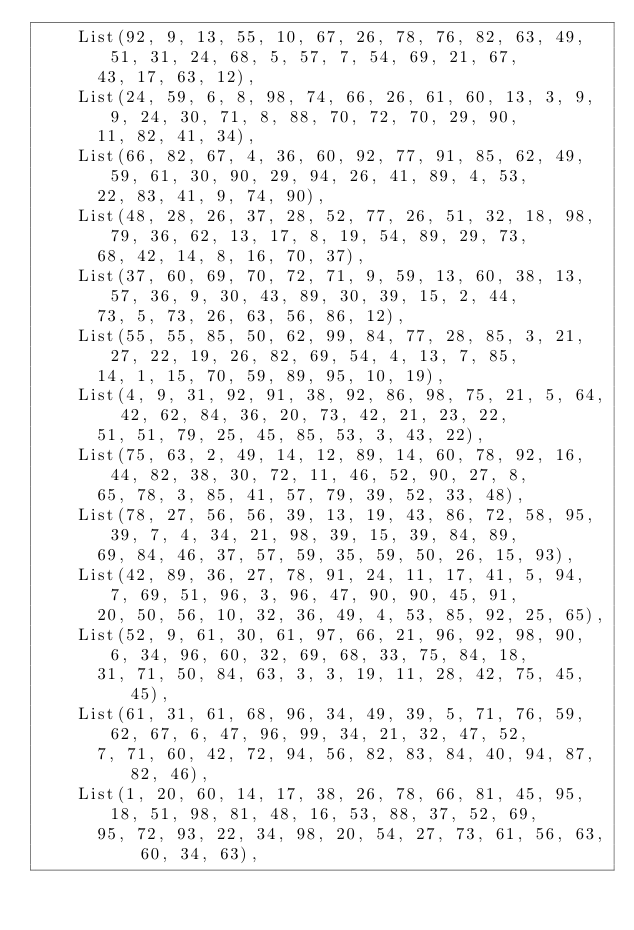Convert code to text. <code><loc_0><loc_0><loc_500><loc_500><_Scala_>    List(92, 9, 13, 55, 10, 67, 26, 78, 76, 82, 63, 49, 51, 31, 24, 68, 5, 57, 7, 54, 69, 21, 67,
      43, 17, 63, 12),
    List(24, 59, 6, 8, 98, 74, 66, 26, 61, 60, 13, 3, 9, 9, 24, 30, 71, 8, 88, 70, 72, 70, 29, 90,
      11, 82, 41, 34),
    List(66, 82, 67, 4, 36, 60, 92, 77, 91, 85, 62, 49, 59, 61, 30, 90, 29, 94, 26, 41, 89, 4, 53,
      22, 83, 41, 9, 74, 90),
    List(48, 28, 26, 37, 28, 52, 77, 26, 51, 32, 18, 98, 79, 36, 62, 13, 17, 8, 19, 54, 89, 29, 73,
      68, 42, 14, 8, 16, 70, 37),
    List(37, 60, 69, 70, 72, 71, 9, 59, 13, 60, 38, 13, 57, 36, 9, 30, 43, 89, 30, 39, 15, 2, 44,
      73, 5, 73, 26, 63, 56, 86, 12),
    List(55, 55, 85, 50, 62, 99, 84, 77, 28, 85, 3, 21, 27, 22, 19, 26, 82, 69, 54, 4, 13, 7, 85,
      14, 1, 15, 70, 59, 89, 95, 10, 19),
    List(4, 9, 31, 92, 91, 38, 92, 86, 98, 75, 21, 5, 64, 42, 62, 84, 36, 20, 73, 42, 21, 23, 22,
      51, 51, 79, 25, 45, 85, 53, 3, 43, 22),
    List(75, 63, 2, 49, 14, 12, 89, 14, 60, 78, 92, 16, 44, 82, 38, 30, 72, 11, 46, 52, 90, 27, 8,
      65, 78, 3, 85, 41, 57, 79, 39, 52, 33, 48),
    List(78, 27, 56, 56, 39, 13, 19, 43, 86, 72, 58, 95, 39, 7, 4, 34, 21, 98, 39, 15, 39, 84, 89,
      69, 84, 46, 37, 57, 59, 35, 59, 50, 26, 15, 93),
    List(42, 89, 36, 27, 78, 91, 24, 11, 17, 41, 5, 94, 7, 69, 51, 96, 3, 96, 47, 90, 90, 45, 91,
      20, 50, 56, 10, 32, 36, 49, 4, 53, 85, 92, 25, 65),
    List(52, 9, 61, 30, 61, 97, 66, 21, 96, 92, 98, 90, 6, 34, 96, 60, 32, 69, 68, 33, 75, 84, 18,
      31, 71, 50, 84, 63, 3, 3, 19, 11, 28, 42, 75, 45, 45),
    List(61, 31, 61, 68, 96, 34, 49, 39, 5, 71, 76, 59, 62, 67, 6, 47, 96, 99, 34, 21, 32, 47, 52,
      7, 71, 60, 42, 72, 94, 56, 82, 83, 84, 40, 94, 87, 82, 46),
    List(1, 20, 60, 14, 17, 38, 26, 78, 66, 81, 45, 95, 18, 51, 98, 81, 48, 16, 53, 88, 37, 52, 69,
      95, 72, 93, 22, 34, 98, 20, 54, 27, 73, 61, 56, 63, 60, 34, 63),</code> 